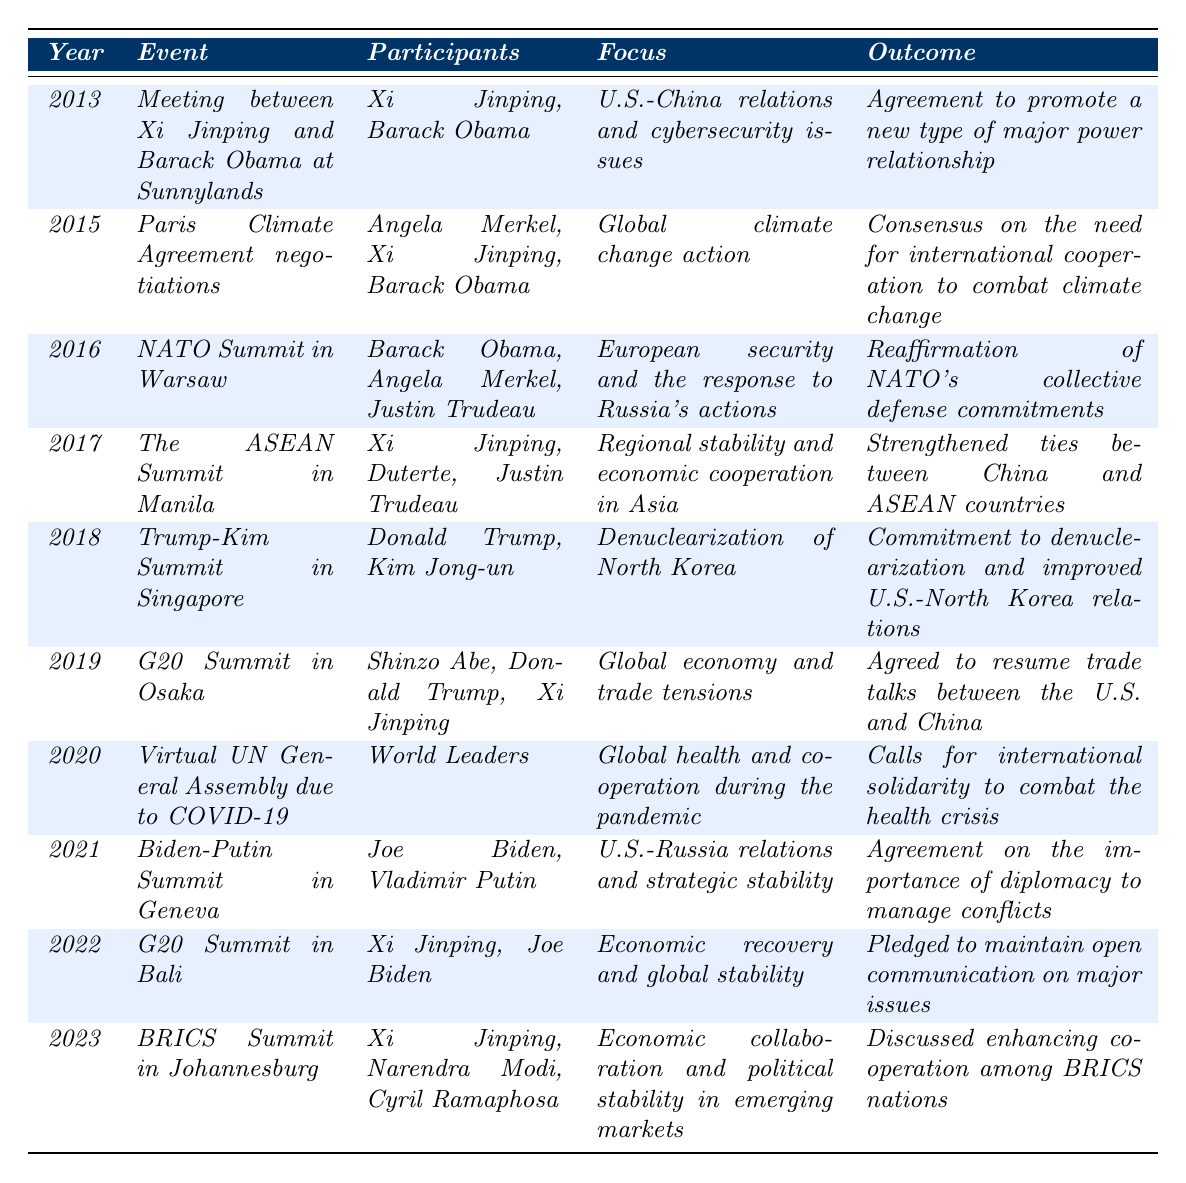What year did the Trump-Kim Summit take place? The table lists the events chronologically. Looking at the entry for the Trump-Kim Summit, it specifically states that it took place in 2018.
Answer: 2018 Who were the participants in the G20 Summit in Osaka? In the table, under the event for the G20 Summit in Osaka, the participants are listed as Shinzo Abe, Donald Trump, and Xi Jinping.
Answer: Shinzo Abe, Donald Trump, Xi Jinping What was the outcome of the Paris Climate Agreement negotiations? The table states that the outcome of the Paris Climate Agreement negotiations was a consensus on the need for international cooperation to combat climate change.
Answer: Consensus on the need for international cooperation to combat climate change How many events involved Xi Jinping as a participant? By reviewing the table, we can count the rows where Xi Jinping appears. There are events in 2013, 2015, 2017, 2018, 2019, 2022, and 2023, which totals to 6 events.
Answer: 6 Was there a meeting focused on the denuclearization of North Korea? The table shows that the Trump-Kim Summit in Singapore was focused on the denuclearization of North Korea. Therefore, the answer to the question is yes.
Answer: Yes What was the main focus of the meeting between Xi Jinping and Barack Obama in 2013? The table indicates that the main focus was U.S.-China relations and cybersecurity issues during their meeting in 2013.
Answer: U.S.-China relations and cybersecurity issues Which event occurred in the same year as the NATO Summit in Warsaw? The table shows that the NATO Summit in Warsaw occurred in 2016. The event taking place in the same year is the meeting involving Barack Obama, Angela Merkel, and Justin Trudeau, highlighting European security.
Answer: None What can you infer about the relationship between U.S.-China trade tensions based on the G20 Summit in Osaka and the G20 Summit in Bali? The table shows that at the G20 Summit in Osaka, there was an agreement to resume trade talks between the U.S. and China, while the G20 Summit in Bali involved Xi Jinping and Joe Biden pledging to maintain communication on major issues. This suggests a continuous effort to address trade tensions.
Answer: Ongoing efforts to address U.S.-China trade tensions What was discussed during the 2023 BRICS Summit in Johannesburg? The table notes that the 2023 BRICS Summit focused on economic collaboration and political stability among emerging markets, with discussions on enhancing cooperation among BRICS nations.
Answer: Enhancing cooperation among BRICS nations How does the outcome of the Virtual UN General Assembly differ from other events? Unlike other events with specific bilateral or multilateral agreements, the Virtual UN General Assembly's outcome was more general, calling for international solidarity to combat the health crisis due to COVID-19. This indicates a broader appeal rather than a direct agreement.
Answer: General call for international solidarity 